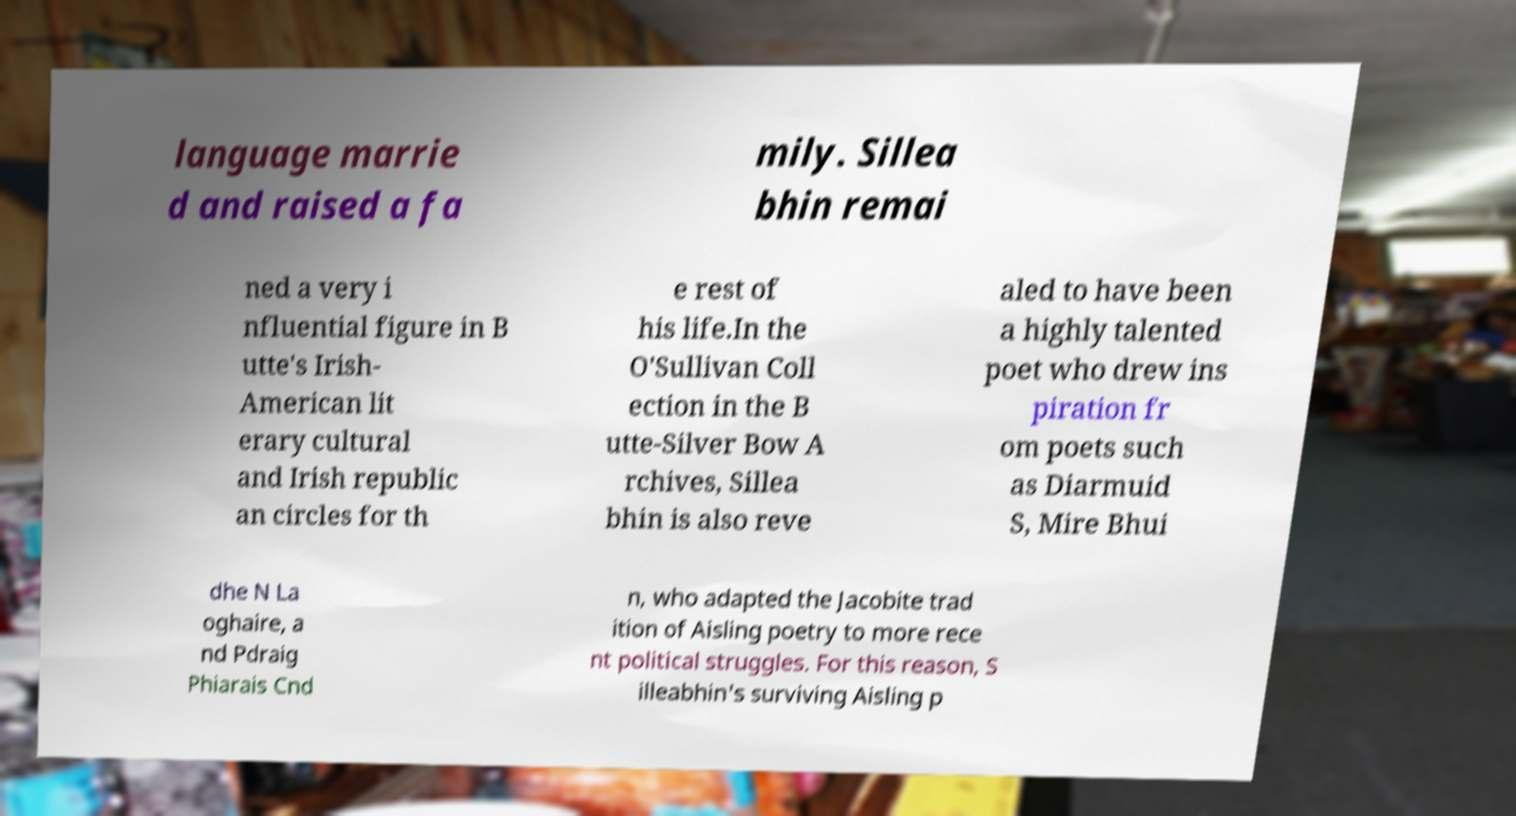I need the written content from this picture converted into text. Can you do that? language marrie d and raised a fa mily. Sillea bhin remai ned a very i nfluential figure in B utte's Irish- American lit erary cultural and Irish republic an circles for th e rest of his life.In the O'Sullivan Coll ection in the B utte-Silver Bow A rchives, Sillea bhin is also reve aled to have been a highly talented poet who drew ins piration fr om poets such as Diarmuid S, Mire Bhui dhe N La oghaire, a nd Pdraig Phiarais Cnd n, who adapted the Jacobite trad ition of Aisling poetry to more rece nt political struggles. For this reason, S illeabhin's surviving Aisling p 